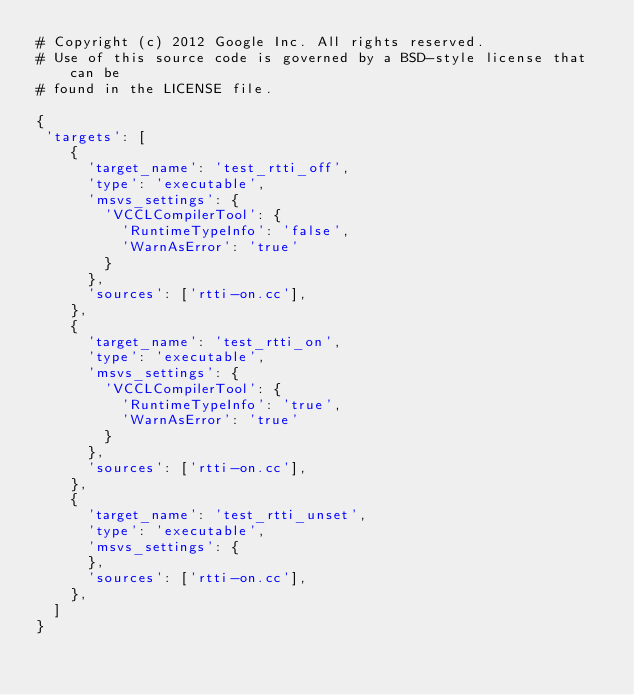Convert code to text. <code><loc_0><loc_0><loc_500><loc_500><_Python_># Copyright (c) 2012 Google Inc. All rights reserved.
# Use of this source code is governed by a BSD-style license that can be
# found in the LICENSE file.

{
 'targets': [
    {
      'target_name': 'test_rtti_off',
      'type': 'executable',
      'msvs_settings': {
        'VCCLCompilerTool': {
          'RuntimeTypeInfo': 'false',
          'WarnAsError': 'true'
        }
      },
      'sources': ['rtti-on.cc'],
    },
    {
      'target_name': 'test_rtti_on',
      'type': 'executable',
      'msvs_settings': {
        'VCCLCompilerTool': {
          'RuntimeTypeInfo': 'true',
          'WarnAsError': 'true'
        }
      },
      'sources': ['rtti-on.cc'],
    },
    {
      'target_name': 'test_rtti_unset',
      'type': 'executable',
      'msvs_settings': {
      },
      'sources': ['rtti-on.cc'],
    },
  ]
}
</code> 